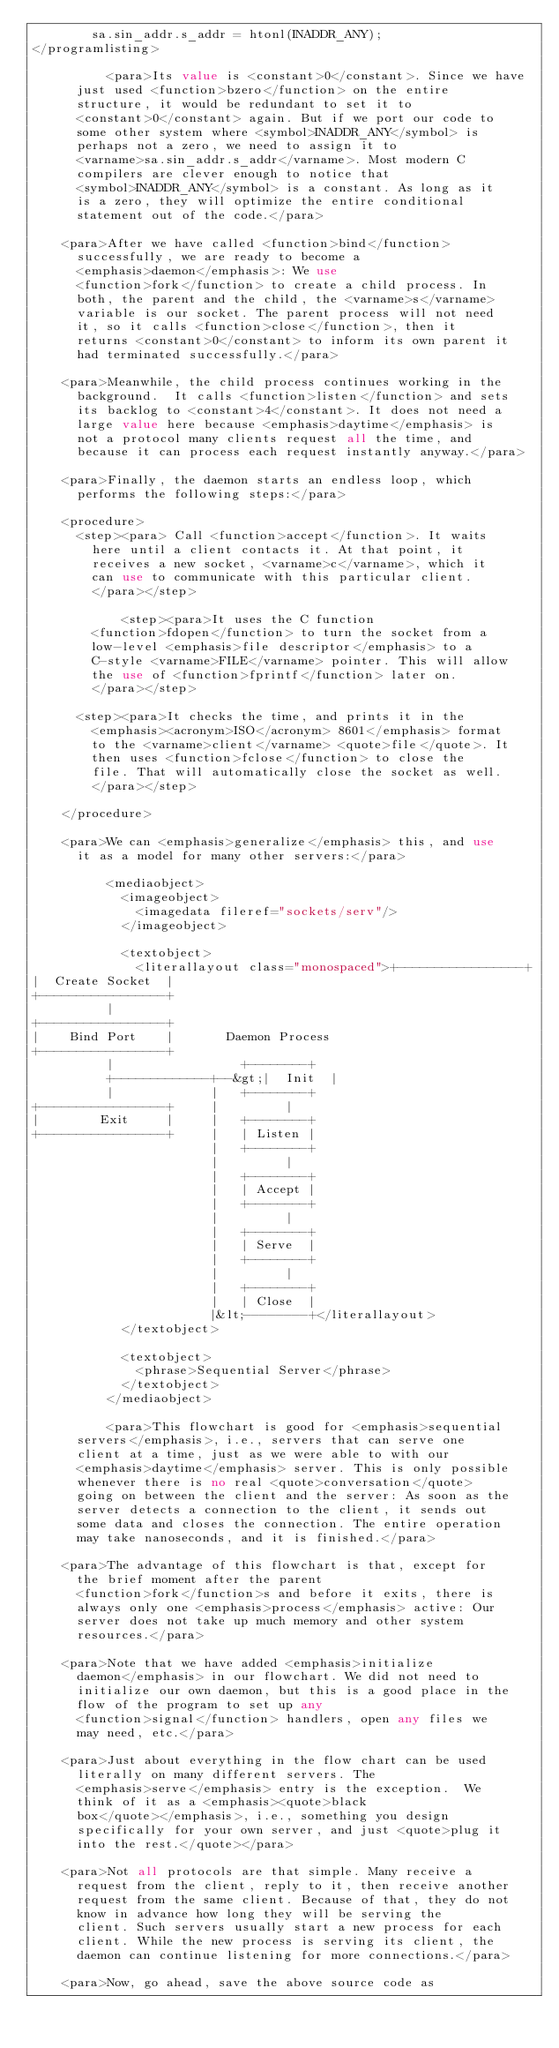<code> <loc_0><loc_0><loc_500><loc_500><_XML_>        sa.sin_addr.s_addr = htonl(INADDR_ANY);
</programlisting>

          <para>Its value is <constant>0</constant>. Since we have
	    just used <function>bzero</function> on the entire
	    structure, it would be redundant to set it to
	    <constant>0</constant> again. But if we port our code to
	    some other system where <symbol>INADDR_ANY</symbol> is
	    perhaps not a zero, we need to assign it to
	    <varname>sa.sin_addr.s_addr</varname>. Most modern C
	    compilers are clever enough to notice that
	    <symbol>INADDR_ANY</symbol> is a constant. As long as it
	    is a zero, they will optimize the entire conditional
	    statement out of the code.</para>

	  <para>After we have called <function>bind</function>
	    successfully, we are ready to become a
	    <emphasis>daemon</emphasis>: We use
	    <function>fork</function> to create a child process. In
	    both, the parent and the child, the <varname>s</varname>
	    variable is our socket. The parent process will not need
	    it, so it calls <function>close</function>, then it
	    returns <constant>0</constant> to inform its own parent it
	    had terminated successfully.</para>

	  <para>Meanwhile, the child process continues working in the
	    background.  It calls <function>listen</function> and sets
	    its backlog to <constant>4</constant>. It does not need a
	    large value here because <emphasis>daytime</emphasis> is
	    not a protocol many clients request all the time, and
	    because it can process each request instantly anyway.</para>

	  <para>Finally, the daemon starts an endless loop, which
	    performs the following steps:</para>

	  <procedure>
	    <step><para> Call <function>accept</function>. It waits
	      here until a client contacts it. At that point, it
	      receives a new socket, <varname>c</varname>, which it
	      can use to communicate with this particular client.
	      </para></step>

            <step><para>It uses the C function
	      <function>fdopen</function> to turn the socket from a
	      low-level <emphasis>file descriptor</emphasis> to a
	      C-style <varname>FILE</varname> pointer. This will allow
	      the use of <function>fprintf</function> later on.
	      </para></step>

	    <step><para>It checks the time, and prints it in the
	      <emphasis><acronym>ISO</acronym> 8601</emphasis> format
	      to the <varname>client</varname> <quote>file</quote>. It
	      then uses <function>fclose</function> to close the
	      file. That will automatically close the socket as well.
	      </para></step>

	  </procedure>

	  <para>We can <emphasis>generalize</emphasis> this, and use
	    it as a model for many other servers:</para>

          <mediaobject>
            <imageobject>
              <imagedata fileref="sockets/serv"/>
            </imageobject>

            <textobject>
              <literallayout class="monospaced">+-----------------+
|  Create Socket  |
+-----------------+
          |
+-----------------+
|    Bind Port    |       Daemon Process
+-----------------+
          |                 +--------+
          +-------------+--&gt;|  Init  |
          |             |   +--------+
+-----------------+     |         |
|        Exit     |     |   +--------+
+-----------------+     |   | Listen |
                        |   +--------+
                        |         |
                        |   +--------+
                        |   | Accept |
                        |   +--------+
                        |         |
                        |   +--------+
                        |   | Serve  |
                        |   +--------+
                        |         |
                        |   +--------+
                        |   | Close  |
                        |&lt;--------+</literallayout>
            </textobject>

            <textobject>
              <phrase>Sequential Server</phrase>
            </textobject>
          </mediaobject>

          <para>This flowchart is good for <emphasis>sequential
	    servers</emphasis>, i.e., servers that can serve one
	    client at a time, just as we were able to with our
	    <emphasis>daytime</emphasis> server. This is only possible
	    whenever there is no real <quote>conversation</quote>
	    going on between the client and the server: As soon as the
	    server detects a connection to the client, it sends out
	    some data and closes the connection. The entire operation
	    may take nanoseconds, and it is finished.</para>

	  <para>The advantage of this flowchart is that, except for
	    the brief moment after the parent
	    <function>fork</function>s and before it exits, there is
	    always only one <emphasis>process</emphasis> active: Our
	    server does not take up much memory and other system
	    resources.</para>

	  <para>Note that we have added <emphasis>initialize
	    daemon</emphasis> in our flowchart. We did not need to
	    initialize our own daemon, but this is a good place in the
	    flow of the program to set up any
	    <function>signal</function> handlers, open any files we
	    may need, etc.</para>

	  <para>Just about everything in the flow chart can be used
	    literally on many different servers. The
	    <emphasis>serve</emphasis> entry is the exception.  We
	    think of it as a <emphasis><quote>black
	    box</quote></emphasis>, i.e., something you design
	    specifically for your own server, and just <quote>plug it
	    into the rest.</quote></para>

	  <para>Not all protocols are that simple. Many receive a
	    request from the client, reply to it, then receive another
	    request from the same client. Because of that, they do not
	    know in advance how long they will be serving the
	    client. Such servers usually start a new process for each
	    client. While the new process is serving its client, the
	    daemon can continue listening for more connections.</para>

	  <para>Now, go ahead, save the above source code as</code> 